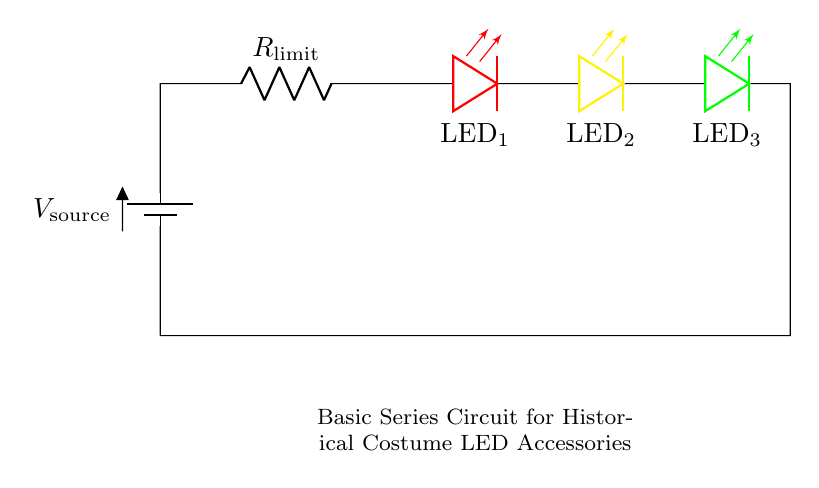What components are in this circuit? The circuit includes a battery, a resistor, and three LEDs. The battery is the power source, the resistor limits the current, and the LEDs light up when current flows.
Answer: battery, resistor, three LEDs What color is the last LED in the series? The last LED in the series, positioned on the right, is green. This can be identified by its color designation in the circuit diagram.
Answer: green How many LEDs are connected in series? There are three LEDs connected in series, as indicated by the diagram showing them aligned one after the other.
Answer: three What is the purpose of the resistor in this circuit? The resistor is used to limit the current flowing through the LEDs to prevent them from burning out. This is crucial because LEDs can be damaged by excessive current.
Answer: limit current If the battery voltage is 9V, what is the total voltage across the LEDs? In a series circuit, the total voltage is shared by the components. Assuming typical forward voltages of around 2V for the red and yellow LEDs, and about 3V for the green LED, the total voltage across them would be approximately 7V. Subtracting this from the battery voltage indicates how much is available across the resistor.
Answer: 7V 